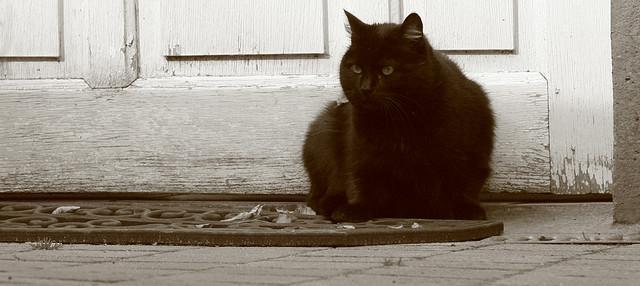How many people in the image are wearing blue?
Give a very brief answer. 0. 